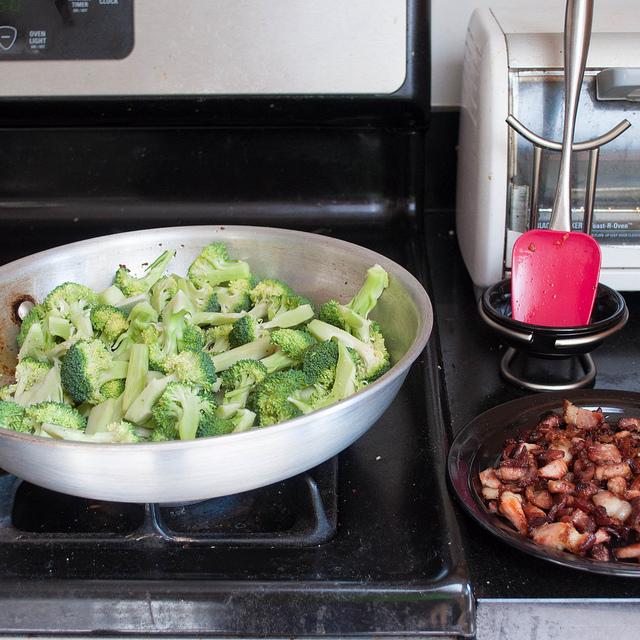Is the stove turned on?
Write a very short answer. No. Is that healthy?
Write a very short answer. Yes. What is in the pan?
Concise answer only. Broccoli. 